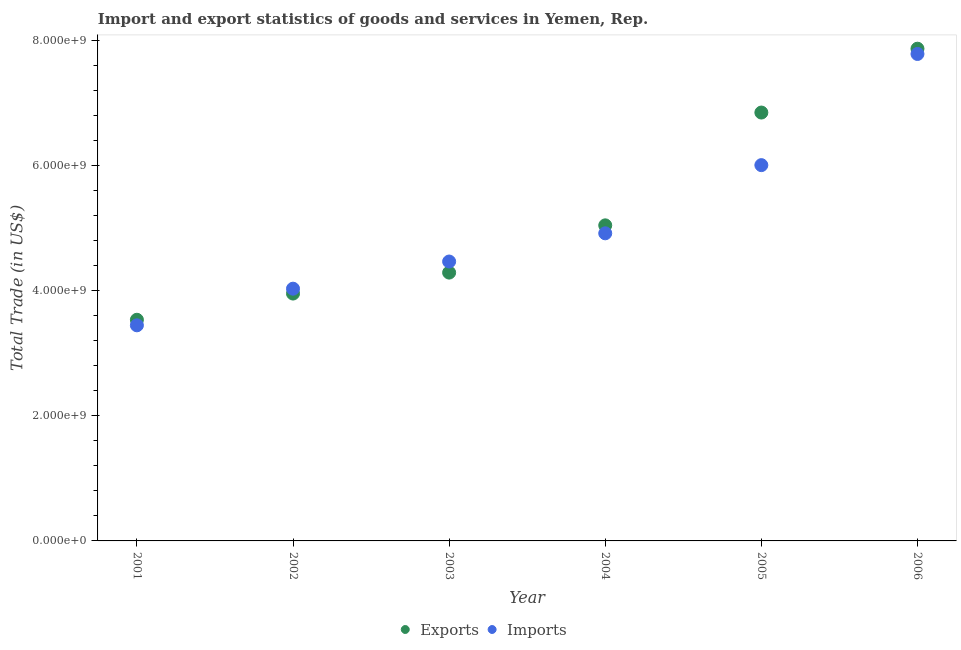What is the export of goods and services in 2005?
Offer a very short reply. 6.85e+09. Across all years, what is the maximum export of goods and services?
Your answer should be very brief. 7.87e+09. Across all years, what is the minimum export of goods and services?
Your answer should be very brief. 3.54e+09. What is the total export of goods and services in the graph?
Your response must be concise. 3.16e+1. What is the difference between the export of goods and services in 2002 and that in 2003?
Offer a terse response. -3.35e+08. What is the difference between the imports of goods and services in 2003 and the export of goods and services in 2005?
Keep it short and to the point. -2.38e+09. What is the average export of goods and services per year?
Your response must be concise. 5.26e+09. In the year 2001, what is the difference between the export of goods and services and imports of goods and services?
Keep it short and to the point. 8.88e+07. What is the ratio of the imports of goods and services in 2004 to that in 2006?
Keep it short and to the point. 0.63. What is the difference between the highest and the second highest imports of goods and services?
Give a very brief answer. 1.78e+09. What is the difference between the highest and the lowest export of goods and services?
Make the answer very short. 4.34e+09. Is the sum of the imports of goods and services in 2003 and 2005 greater than the maximum export of goods and services across all years?
Ensure brevity in your answer.  Yes. Is the export of goods and services strictly less than the imports of goods and services over the years?
Offer a terse response. No. How many dotlines are there?
Make the answer very short. 2. How many years are there in the graph?
Offer a very short reply. 6. Where does the legend appear in the graph?
Make the answer very short. Bottom center. How many legend labels are there?
Ensure brevity in your answer.  2. How are the legend labels stacked?
Make the answer very short. Horizontal. What is the title of the graph?
Your answer should be very brief. Import and export statistics of goods and services in Yemen, Rep. Does "UN agencies" appear as one of the legend labels in the graph?
Ensure brevity in your answer.  No. What is the label or title of the X-axis?
Your response must be concise. Year. What is the label or title of the Y-axis?
Offer a very short reply. Total Trade (in US$). What is the Total Trade (in US$) in Exports in 2001?
Your answer should be very brief. 3.54e+09. What is the Total Trade (in US$) of Imports in 2001?
Your answer should be compact. 3.45e+09. What is the Total Trade (in US$) of Exports in 2002?
Offer a terse response. 3.96e+09. What is the Total Trade (in US$) in Imports in 2002?
Provide a succinct answer. 4.03e+09. What is the Total Trade (in US$) of Exports in 2003?
Give a very brief answer. 4.29e+09. What is the Total Trade (in US$) in Imports in 2003?
Make the answer very short. 4.47e+09. What is the Total Trade (in US$) of Exports in 2004?
Offer a terse response. 5.05e+09. What is the Total Trade (in US$) in Imports in 2004?
Your answer should be very brief. 4.92e+09. What is the Total Trade (in US$) in Exports in 2005?
Provide a short and direct response. 6.85e+09. What is the Total Trade (in US$) in Imports in 2005?
Ensure brevity in your answer.  6.01e+09. What is the Total Trade (in US$) in Exports in 2006?
Give a very brief answer. 7.87e+09. What is the Total Trade (in US$) in Imports in 2006?
Provide a short and direct response. 7.79e+09. Across all years, what is the maximum Total Trade (in US$) of Exports?
Keep it short and to the point. 7.87e+09. Across all years, what is the maximum Total Trade (in US$) in Imports?
Provide a succinct answer. 7.79e+09. Across all years, what is the minimum Total Trade (in US$) of Exports?
Provide a short and direct response. 3.54e+09. Across all years, what is the minimum Total Trade (in US$) of Imports?
Give a very brief answer. 3.45e+09. What is the total Total Trade (in US$) of Exports in the graph?
Give a very brief answer. 3.16e+1. What is the total Total Trade (in US$) in Imports in the graph?
Make the answer very short. 3.07e+1. What is the difference between the Total Trade (in US$) in Exports in 2001 and that in 2002?
Keep it short and to the point. -4.19e+08. What is the difference between the Total Trade (in US$) of Imports in 2001 and that in 2002?
Ensure brevity in your answer.  -5.86e+08. What is the difference between the Total Trade (in US$) of Exports in 2001 and that in 2003?
Provide a succinct answer. -7.54e+08. What is the difference between the Total Trade (in US$) in Imports in 2001 and that in 2003?
Keep it short and to the point. -1.02e+09. What is the difference between the Total Trade (in US$) of Exports in 2001 and that in 2004?
Provide a succinct answer. -1.51e+09. What is the difference between the Total Trade (in US$) in Imports in 2001 and that in 2004?
Your answer should be compact. -1.47e+09. What is the difference between the Total Trade (in US$) of Exports in 2001 and that in 2005?
Ensure brevity in your answer.  -3.31e+09. What is the difference between the Total Trade (in US$) in Imports in 2001 and that in 2005?
Your answer should be very brief. -2.56e+09. What is the difference between the Total Trade (in US$) of Exports in 2001 and that in 2006?
Your response must be concise. -4.34e+09. What is the difference between the Total Trade (in US$) of Imports in 2001 and that in 2006?
Provide a short and direct response. -4.34e+09. What is the difference between the Total Trade (in US$) in Exports in 2002 and that in 2003?
Offer a terse response. -3.35e+08. What is the difference between the Total Trade (in US$) of Imports in 2002 and that in 2003?
Your response must be concise. -4.34e+08. What is the difference between the Total Trade (in US$) of Exports in 2002 and that in 2004?
Keep it short and to the point. -1.09e+09. What is the difference between the Total Trade (in US$) in Imports in 2002 and that in 2004?
Your answer should be very brief. -8.86e+08. What is the difference between the Total Trade (in US$) of Exports in 2002 and that in 2005?
Offer a terse response. -2.90e+09. What is the difference between the Total Trade (in US$) of Imports in 2002 and that in 2005?
Your answer should be compact. -1.98e+09. What is the difference between the Total Trade (in US$) in Exports in 2002 and that in 2006?
Offer a very short reply. -3.92e+09. What is the difference between the Total Trade (in US$) in Imports in 2002 and that in 2006?
Give a very brief answer. -3.75e+09. What is the difference between the Total Trade (in US$) in Exports in 2003 and that in 2004?
Your answer should be very brief. -7.56e+08. What is the difference between the Total Trade (in US$) in Imports in 2003 and that in 2004?
Give a very brief answer. -4.51e+08. What is the difference between the Total Trade (in US$) of Exports in 2003 and that in 2005?
Make the answer very short. -2.56e+09. What is the difference between the Total Trade (in US$) in Imports in 2003 and that in 2005?
Give a very brief answer. -1.54e+09. What is the difference between the Total Trade (in US$) in Exports in 2003 and that in 2006?
Give a very brief answer. -3.58e+09. What is the difference between the Total Trade (in US$) of Imports in 2003 and that in 2006?
Provide a succinct answer. -3.32e+09. What is the difference between the Total Trade (in US$) in Exports in 2004 and that in 2005?
Provide a succinct answer. -1.80e+09. What is the difference between the Total Trade (in US$) of Imports in 2004 and that in 2005?
Offer a terse response. -1.09e+09. What is the difference between the Total Trade (in US$) of Exports in 2004 and that in 2006?
Give a very brief answer. -2.83e+09. What is the difference between the Total Trade (in US$) in Imports in 2004 and that in 2006?
Your response must be concise. -2.87e+09. What is the difference between the Total Trade (in US$) of Exports in 2005 and that in 2006?
Offer a terse response. -1.02e+09. What is the difference between the Total Trade (in US$) in Imports in 2005 and that in 2006?
Your response must be concise. -1.78e+09. What is the difference between the Total Trade (in US$) in Exports in 2001 and the Total Trade (in US$) in Imports in 2002?
Keep it short and to the point. -4.97e+08. What is the difference between the Total Trade (in US$) in Exports in 2001 and the Total Trade (in US$) in Imports in 2003?
Your response must be concise. -9.32e+08. What is the difference between the Total Trade (in US$) in Exports in 2001 and the Total Trade (in US$) in Imports in 2004?
Your answer should be compact. -1.38e+09. What is the difference between the Total Trade (in US$) of Exports in 2001 and the Total Trade (in US$) of Imports in 2005?
Your response must be concise. -2.47e+09. What is the difference between the Total Trade (in US$) of Exports in 2001 and the Total Trade (in US$) of Imports in 2006?
Provide a short and direct response. -4.25e+09. What is the difference between the Total Trade (in US$) in Exports in 2002 and the Total Trade (in US$) in Imports in 2003?
Give a very brief answer. -5.12e+08. What is the difference between the Total Trade (in US$) in Exports in 2002 and the Total Trade (in US$) in Imports in 2004?
Keep it short and to the point. -9.63e+08. What is the difference between the Total Trade (in US$) of Exports in 2002 and the Total Trade (in US$) of Imports in 2005?
Provide a succinct answer. -2.05e+09. What is the difference between the Total Trade (in US$) in Exports in 2002 and the Total Trade (in US$) in Imports in 2006?
Your response must be concise. -3.83e+09. What is the difference between the Total Trade (in US$) in Exports in 2003 and the Total Trade (in US$) in Imports in 2004?
Your answer should be very brief. -6.28e+08. What is the difference between the Total Trade (in US$) of Exports in 2003 and the Total Trade (in US$) of Imports in 2005?
Give a very brief answer. -1.72e+09. What is the difference between the Total Trade (in US$) of Exports in 2003 and the Total Trade (in US$) of Imports in 2006?
Provide a succinct answer. -3.50e+09. What is the difference between the Total Trade (in US$) in Exports in 2004 and the Total Trade (in US$) in Imports in 2005?
Your answer should be very brief. -9.63e+08. What is the difference between the Total Trade (in US$) of Exports in 2004 and the Total Trade (in US$) of Imports in 2006?
Make the answer very short. -2.74e+09. What is the difference between the Total Trade (in US$) in Exports in 2005 and the Total Trade (in US$) in Imports in 2006?
Your response must be concise. -9.37e+08. What is the average Total Trade (in US$) of Exports per year?
Keep it short and to the point. 5.26e+09. What is the average Total Trade (in US$) of Imports per year?
Your answer should be compact. 5.11e+09. In the year 2001, what is the difference between the Total Trade (in US$) of Exports and Total Trade (in US$) of Imports?
Ensure brevity in your answer.  8.88e+07. In the year 2002, what is the difference between the Total Trade (in US$) in Exports and Total Trade (in US$) in Imports?
Provide a succinct answer. -7.79e+07. In the year 2003, what is the difference between the Total Trade (in US$) of Exports and Total Trade (in US$) of Imports?
Offer a terse response. -1.77e+08. In the year 2004, what is the difference between the Total Trade (in US$) in Exports and Total Trade (in US$) in Imports?
Your answer should be compact. 1.27e+08. In the year 2005, what is the difference between the Total Trade (in US$) in Exports and Total Trade (in US$) in Imports?
Offer a very short reply. 8.41e+08. In the year 2006, what is the difference between the Total Trade (in US$) of Exports and Total Trade (in US$) of Imports?
Give a very brief answer. 8.42e+07. What is the ratio of the Total Trade (in US$) of Exports in 2001 to that in 2002?
Your answer should be compact. 0.89. What is the ratio of the Total Trade (in US$) of Imports in 2001 to that in 2002?
Make the answer very short. 0.85. What is the ratio of the Total Trade (in US$) in Exports in 2001 to that in 2003?
Offer a very short reply. 0.82. What is the ratio of the Total Trade (in US$) in Imports in 2001 to that in 2003?
Your answer should be compact. 0.77. What is the ratio of the Total Trade (in US$) in Exports in 2001 to that in 2004?
Provide a succinct answer. 0.7. What is the ratio of the Total Trade (in US$) of Imports in 2001 to that in 2004?
Provide a short and direct response. 0.7. What is the ratio of the Total Trade (in US$) of Exports in 2001 to that in 2005?
Offer a very short reply. 0.52. What is the ratio of the Total Trade (in US$) in Imports in 2001 to that in 2005?
Your answer should be compact. 0.57. What is the ratio of the Total Trade (in US$) of Exports in 2001 to that in 2006?
Provide a short and direct response. 0.45. What is the ratio of the Total Trade (in US$) in Imports in 2001 to that in 2006?
Keep it short and to the point. 0.44. What is the ratio of the Total Trade (in US$) in Exports in 2002 to that in 2003?
Make the answer very short. 0.92. What is the ratio of the Total Trade (in US$) in Imports in 2002 to that in 2003?
Provide a succinct answer. 0.9. What is the ratio of the Total Trade (in US$) in Exports in 2002 to that in 2004?
Keep it short and to the point. 0.78. What is the ratio of the Total Trade (in US$) in Imports in 2002 to that in 2004?
Your response must be concise. 0.82. What is the ratio of the Total Trade (in US$) in Exports in 2002 to that in 2005?
Offer a very short reply. 0.58. What is the ratio of the Total Trade (in US$) of Imports in 2002 to that in 2005?
Make the answer very short. 0.67. What is the ratio of the Total Trade (in US$) in Exports in 2002 to that in 2006?
Your response must be concise. 0.5. What is the ratio of the Total Trade (in US$) in Imports in 2002 to that in 2006?
Ensure brevity in your answer.  0.52. What is the ratio of the Total Trade (in US$) of Exports in 2003 to that in 2004?
Give a very brief answer. 0.85. What is the ratio of the Total Trade (in US$) in Imports in 2003 to that in 2004?
Your answer should be very brief. 0.91. What is the ratio of the Total Trade (in US$) of Exports in 2003 to that in 2005?
Offer a terse response. 0.63. What is the ratio of the Total Trade (in US$) in Imports in 2003 to that in 2005?
Offer a very short reply. 0.74. What is the ratio of the Total Trade (in US$) of Exports in 2003 to that in 2006?
Ensure brevity in your answer.  0.55. What is the ratio of the Total Trade (in US$) in Imports in 2003 to that in 2006?
Provide a short and direct response. 0.57. What is the ratio of the Total Trade (in US$) in Exports in 2004 to that in 2005?
Offer a very short reply. 0.74. What is the ratio of the Total Trade (in US$) in Imports in 2004 to that in 2005?
Provide a short and direct response. 0.82. What is the ratio of the Total Trade (in US$) of Exports in 2004 to that in 2006?
Your answer should be very brief. 0.64. What is the ratio of the Total Trade (in US$) of Imports in 2004 to that in 2006?
Your response must be concise. 0.63. What is the ratio of the Total Trade (in US$) of Exports in 2005 to that in 2006?
Make the answer very short. 0.87. What is the ratio of the Total Trade (in US$) in Imports in 2005 to that in 2006?
Give a very brief answer. 0.77. What is the difference between the highest and the second highest Total Trade (in US$) in Exports?
Make the answer very short. 1.02e+09. What is the difference between the highest and the second highest Total Trade (in US$) in Imports?
Provide a succinct answer. 1.78e+09. What is the difference between the highest and the lowest Total Trade (in US$) of Exports?
Provide a succinct answer. 4.34e+09. What is the difference between the highest and the lowest Total Trade (in US$) in Imports?
Make the answer very short. 4.34e+09. 